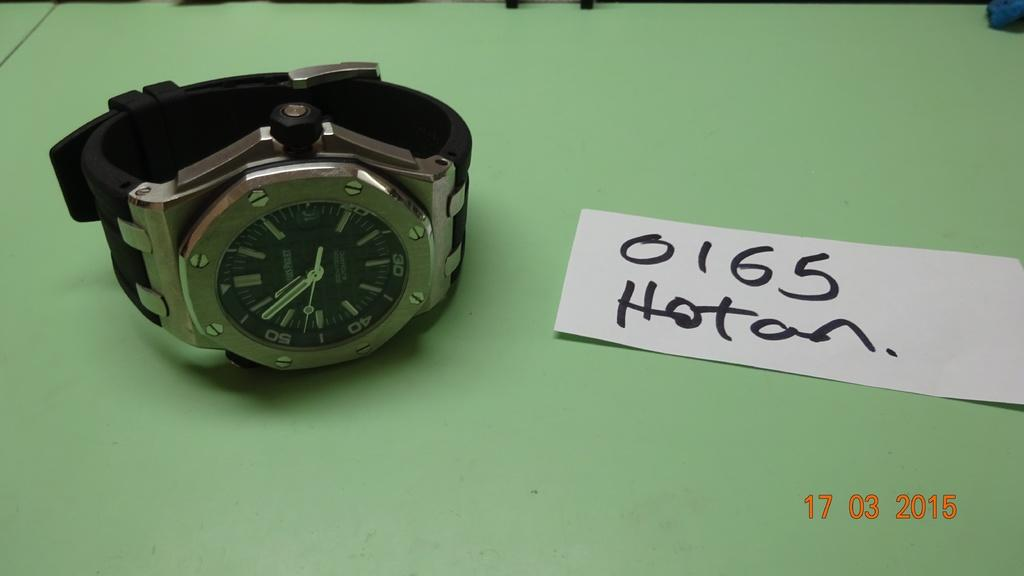<image>
Provide a brief description of the given image. A man's wristwatch is shown on a flat surface with a paper nearby saying 0165 Hoton with photo date stamped 17 03 2015. 